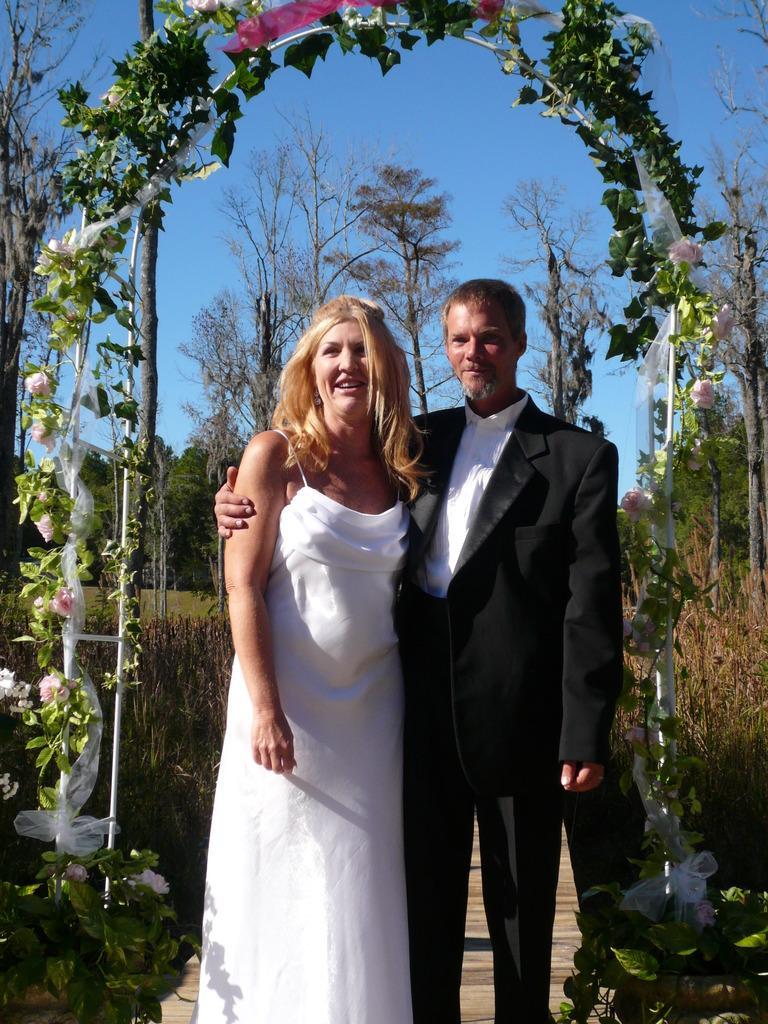Could you give a brief overview of what you see in this image? In this image I can see a man and a woman are standing together and smiling. The man is wearing a shirt and a black coat. The woman is wearing a white dress. In the background I can see trees, flowers, plants and the sky. 